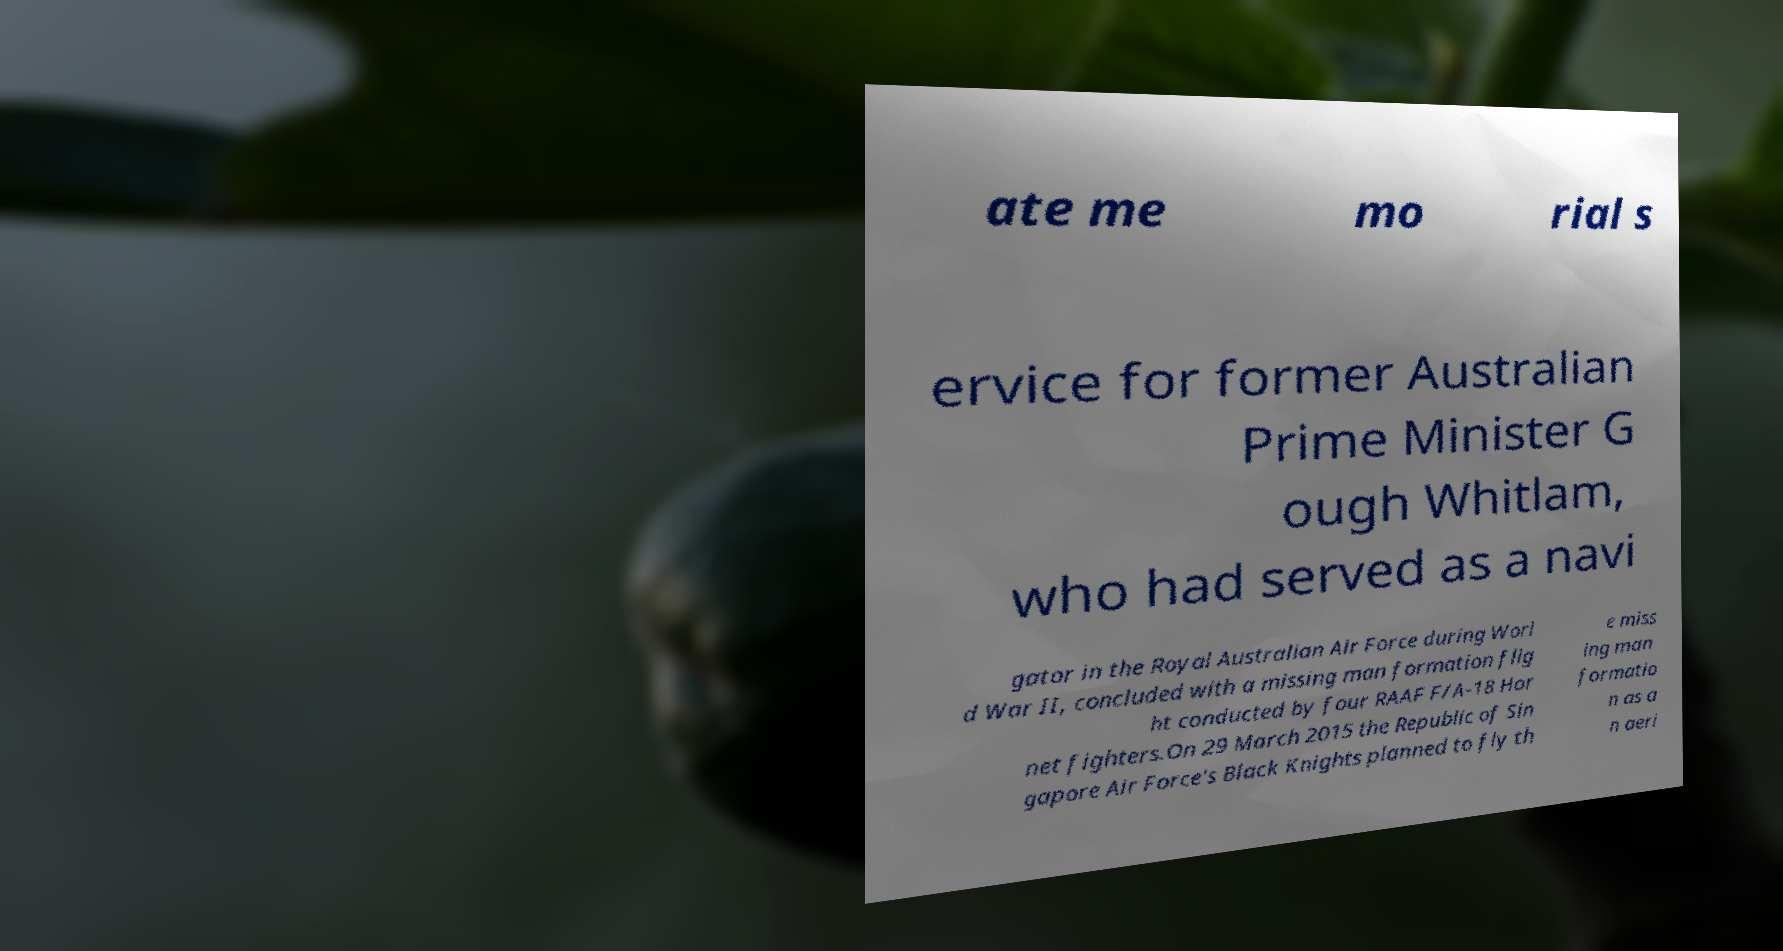I need the written content from this picture converted into text. Can you do that? ate me mo rial s ervice for former Australian Prime Minister G ough Whitlam, who had served as a navi gator in the Royal Australian Air Force during Worl d War II, concluded with a missing man formation flig ht conducted by four RAAF F/A-18 Hor net fighters.On 29 March 2015 the Republic of Sin gapore Air Force's Black Knights planned to fly th e miss ing man formatio n as a n aeri 